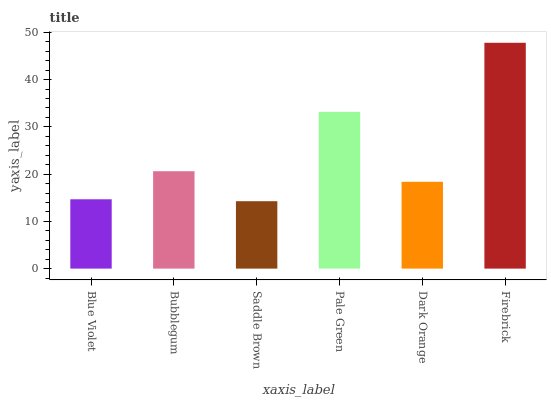Is Saddle Brown the minimum?
Answer yes or no. Yes. Is Firebrick the maximum?
Answer yes or no. Yes. Is Bubblegum the minimum?
Answer yes or no. No. Is Bubblegum the maximum?
Answer yes or no. No. Is Bubblegum greater than Blue Violet?
Answer yes or no. Yes. Is Blue Violet less than Bubblegum?
Answer yes or no. Yes. Is Blue Violet greater than Bubblegum?
Answer yes or no. No. Is Bubblegum less than Blue Violet?
Answer yes or no. No. Is Bubblegum the high median?
Answer yes or no. Yes. Is Dark Orange the low median?
Answer yes or no. Yes. Is Saddle Brown the high median?
Answer yes or no. No. Is Blue Violet the low median?
Answer yes or no. No. 